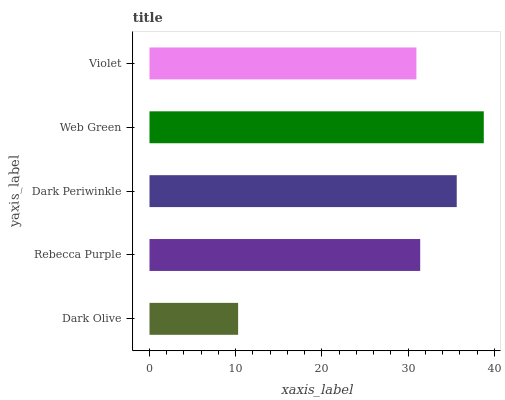Is Dark Olive the minimum?
Answer yes or no. Yes. Is Web Green the maximum?
Answer yes or no. Yes. Is Rebecca Purple the minimum?
Answer yes or no. No. Is Rebecca Purple the maximum?
Answer yes or no. No. Is Rebecca Purple greater than Dark Olive?
Answer yes or no. Yes. Is Dark Olive less than Rebecca Purple?
Answer yes or no. Yes. Is Dark Olive greater than Rebecca Purple?
Answer yes or no. No. Is Rebecca Purple less than Dark Olive?
Answer yes or no. No. Is Rebecca Purple the high median?
Answer yes or no. Yes. Is Rebecca Purple the low median?
Answer yes or no. Yes. Is Dark Periwinkle the high median?
Answer yes or no. No. Is Dark Olive the low median?
Answer yes or no. No. 